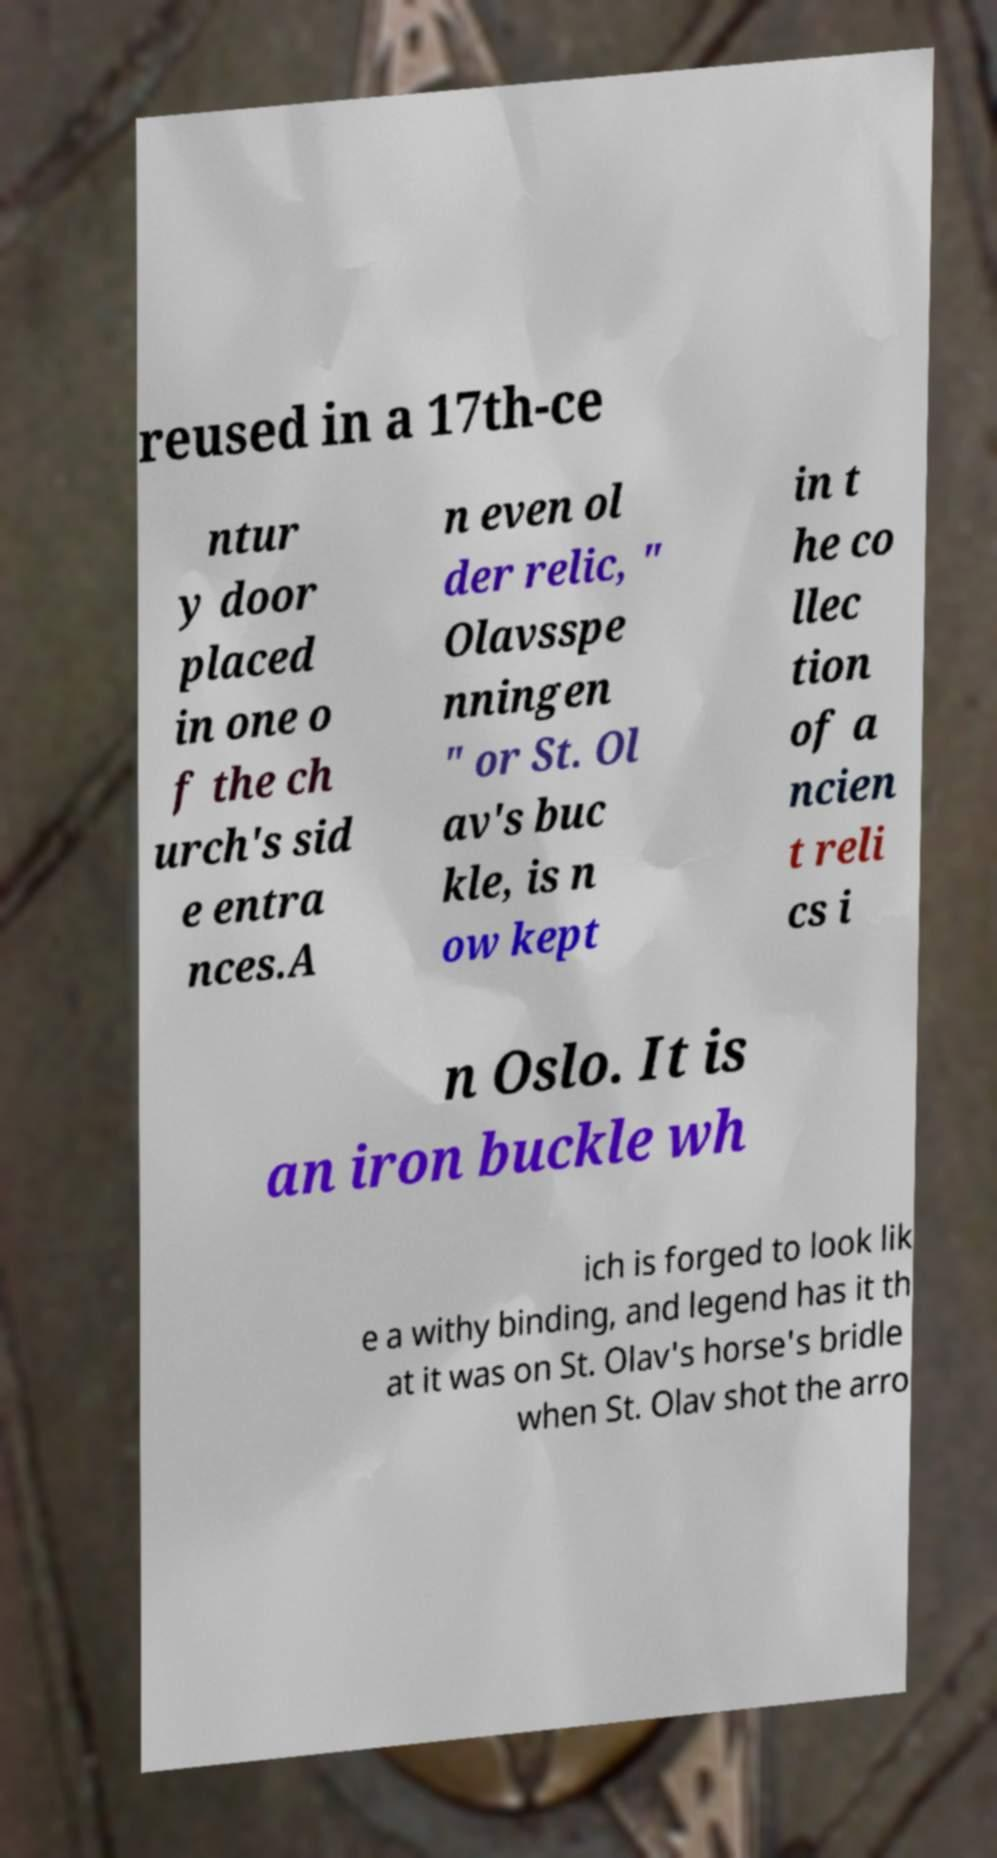For documentation purposes, I need the text within this image transcribed. Could you provide that? reused in a 17th-ce ntur y door placed in one o f the ch urch's sid e entra nces.A n even ol der relic, " Olavsspe nningen " or St. Ol av's buc kle, is n ow kept in t he co llec tion of a ncien t reli cs i n Oslo. It is an iron buckle wh ich is forged to look lik e a withy binding, and legend has it th at it was on St. Olav's horse's bridle when St. Olav shot the arro 